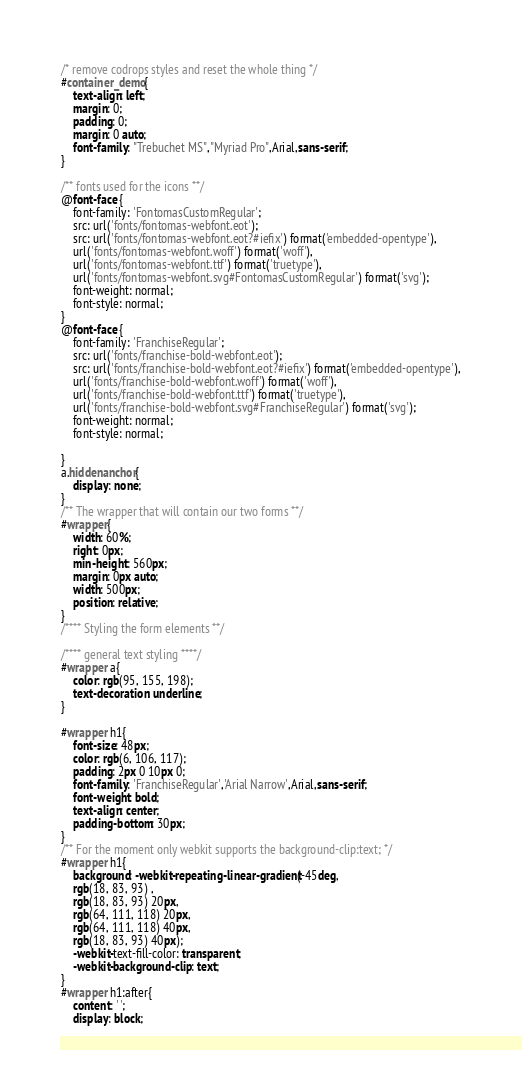Convert code to text. <code><loc_0><loc_0><loc_500><loc_500><_CSS_>/* remove codrops styles and reset the whole thing */
#container_demo{
    text-align: left;
    margin: 0;
    padding: 0;
    margin: 0 auto;
    font-family: "Trebuchet MS","Myriad Pro",Arial,sans-serif;
}

/** fonts used for the icons **/
@font-face {
    font-family: 'FontomasCustomRegular';
    src: url('fonts/fontomas-webfont.eot');
    src: url('fonts/fontomas-webfont.eot?#iefix') format('embedded-opentype'),
    url('fonts/fontomas-webfont.woff') format('woff'),
    url('fonts/fontomas-webfont.ttf') format('truetype'),
    url('fonts/fontomas-webfont.svg#FontomasCustomRegular') format('svg');
    font-weight: normal;
    font-style: normal;
}
@font-face {
    font-family: 'FranchiseRegular';
    src: url('fonts/franchise-bold-webfont.eot');
    src: url('fonts/franchise-bold-webfont.eot?#iefix') format('embedded-opentype'),
    url('fonts/franchise-bold-webfont.woff') format('woff'),
    url('fonts/franchise-bold-webfont.ttf') format('truetype'),
    url('fonts/franchise-bold-webfont.svg#FranchiseRegular') format('svg');
    font-weight: normal;
    font-style: normal;

}
a.hiddenanchor{
    display: none;
}
/** The wrapper that will contain our two forms **/
#wrapper{
    width: 60%;
    right: 0px;
    min-height: 560px;
    margin: 0px auto;
    width: 500px;
    position: relative;
}
/**** Styling the form elements **/

/**** general text styling ****/
#wrapper a{
    color: rgb(95, 155, 198);
    text-decoration: underline;
}

#wrapper h1{
    font-size: 48px;
    color: rgb(6, 106, 117);
    padding: 2px 0 10px 0;
    font-family: 'FranchiseRegular','Arial Narrow',Arial,sans-serif;
    font-weight: bold;
    text-align: center;
    padding-bottom: 30px;
}
/** For the moment only webkit supports the background-clip:text; */
#wrapper h1{
    background: -webkit-repeating-linear-gradient(-45deg,
    rgb(18, 83, 93) ,
    rgb(18, 83, 93) 20px,
    rgb(64, 111, 118) 20px,
    rgb(64, 111, 118) 40px,
    rgb(18, 83, 93) 40px);
    -webkit-text-fill-color: transparent;
    -webkit-background-clip: text;
}
#wrapper h1:after{
    content: ' ';
    display: block;</code> 